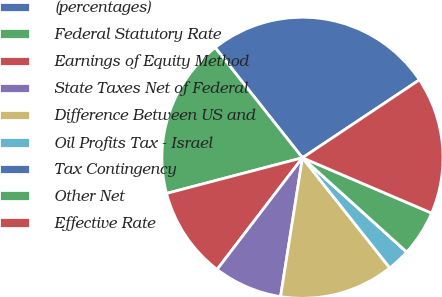Convert chart. <chart><loc_0><loc_0><loc_500><loc_500><pie_chart><fcel>(percentages)<fcel>Federal Statutory Rate<fcel>Earnings of Equity Method<fcel>State Taxes Net of Federal<fcel>Difference Between US and<fcel>Oil Profits Tax - Israel<fcel>Tax Contingency<fcel>Other Net<fcel>Effective Rate<nl><fcel>26.31%<fcel>18.42%<fcel>10.53%<fcel>7.9%<fcel>13.16%<fcel>2.63%<fcel>0.0%<fcel>5.26%<fcel>15.79%<nl></chart> 